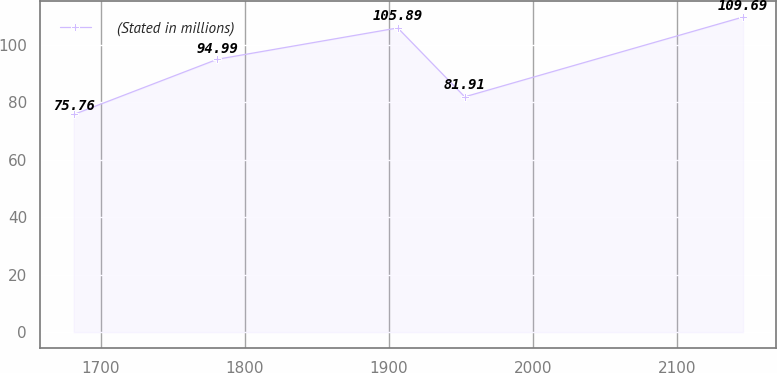Convert chart. <chart><loc_0><loc_0><loc_500><loc_500><line_chart><ecel><fcel>(Stated in millions)<nl><fcel>1681.21<fcel>75.76<nl><fcel>1780.99<fcel>94.99<nl><fcel>1906.2<fcel>105.89<nl><fcel>1952.67<fcel>81.91<nl><fcel>2145.91<fcel>109.69<nl></chart> 